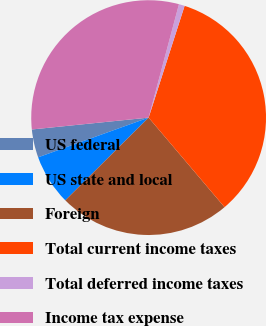Convert chart. <chart><loc_0><loc_0><loc_500><loc_500><pie_chart><fcel>US federal<fcel>US state and local<fcel>Foreign<fcel>Total current income taxes<fcel>Total deferred income taxes<fcel>Income tax expense<nl><fcel>3.88%<fcel>6.95%<fcel>23.75%<fcel>33.85%<fcel>0.8%<fcel>30.77%<nl></chart> 